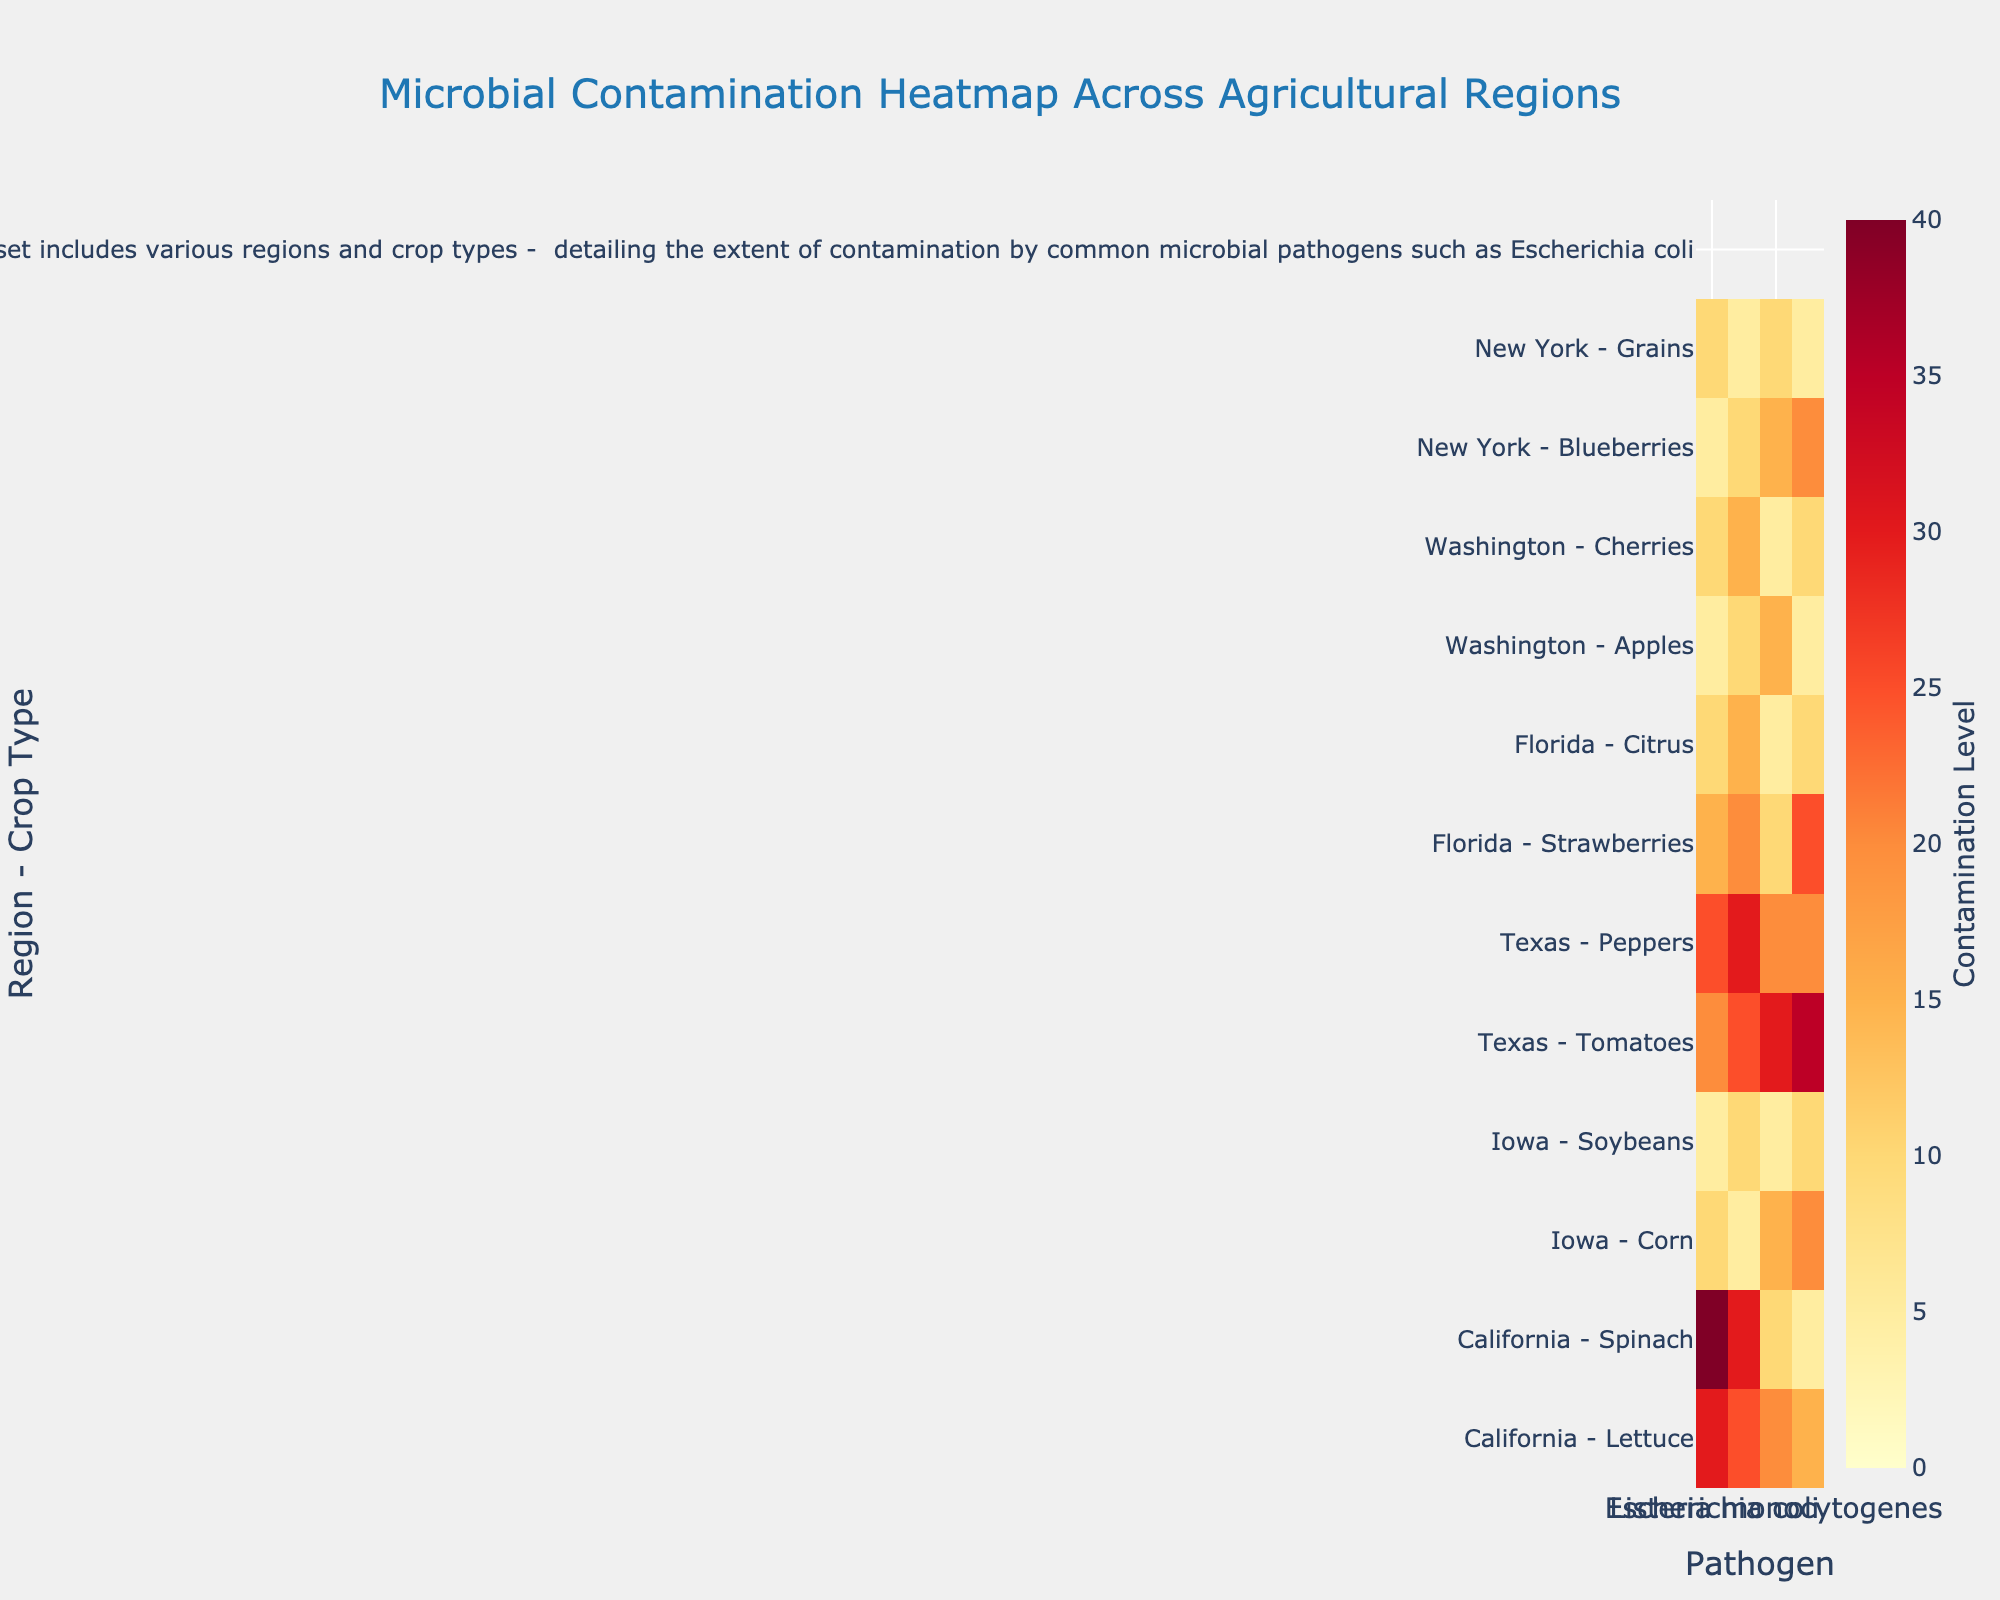How many regions are represented in the heatmap? The heatmap shows data for six distinct regions, which are represented along the y-axis labeled with both the region and crop type.
Answer: Six What is the maximum contamination level for Salmonella in any crop type across the regions? By inspecting the heatmap and the color gradient, the highest value for Salmonella contamination is identified as 30, occurring in both Spinach in California and Peppers in Texas.
Answer: 30 Which region and crop type combination has the highest contamination level for Campylobacter? The highest value for Campylobacter can be identified by looking for the darkest color shade in the Campylobacter column. It is 35, recorded for Tomatoes in Texas.
Answer: Texas - Tomatoes In which region does the crop “Apples” show contamination for Listeria monocytogenes, and what is the contamination level? Locate “Washington - Apples” on the y-axis, then trace horizontally to the Listeria monocytogenes column to find the contamination level, which is 15.
Answer: Washington, 15 Compare the contamination levels of Escherichia coli between Lettuce in California and Corn in Iowa. Which is higher? Locate “California - Lettuce” and “Iowa - Corn” rows on the y-axis, then trace horizontally to the Escherichia coli column. California-Lettuce has a value of 30, while Iowa-Corn has 10. Hence, California-Lettuce is higher.
Answer: California - Lettuce Which crop type in Florida has a higher contamination of Salmonella, Strawberries or Citrus? Compare the Salmonella values for “Florida - Strawberries” and “Florida - Citrus.” Strawberries have a contamination level of 20, while Citrus has 15.
Answer: Strawberries Calculate the average contamination level of all pathogens for Blueberries in New York. Find all contamination levels for “New York - Blueberries,” which are: 5 (E. coli), 10 (Salmonella), 15 (Listeria monocytogenes), and 20 (Campylobacter). Sum these values (5 + 10 + 15 + 20 = 50) and divide by 4 (number of pathogens), resulting in an average of 12.5.
Answer: 12.5 What is the most contaminated crop type for Escherichia coli among the regions, and what is the level? By looking at the Escherichia coli column, scan for the darkest shade, which corresponds to the highest value. Spinach in California has the highest E. coli contamination at 40.
Answer: Spinach, 40 Which crop type in Iowa has a higher total contamination level when adding across all pathogens? Calculate the total contamination for Corn (10+5+15+20 = 50) and for Soybeans (5+10+5+10 = 30). Corn has a higher total contamination level.
Answer: Corn, 50 